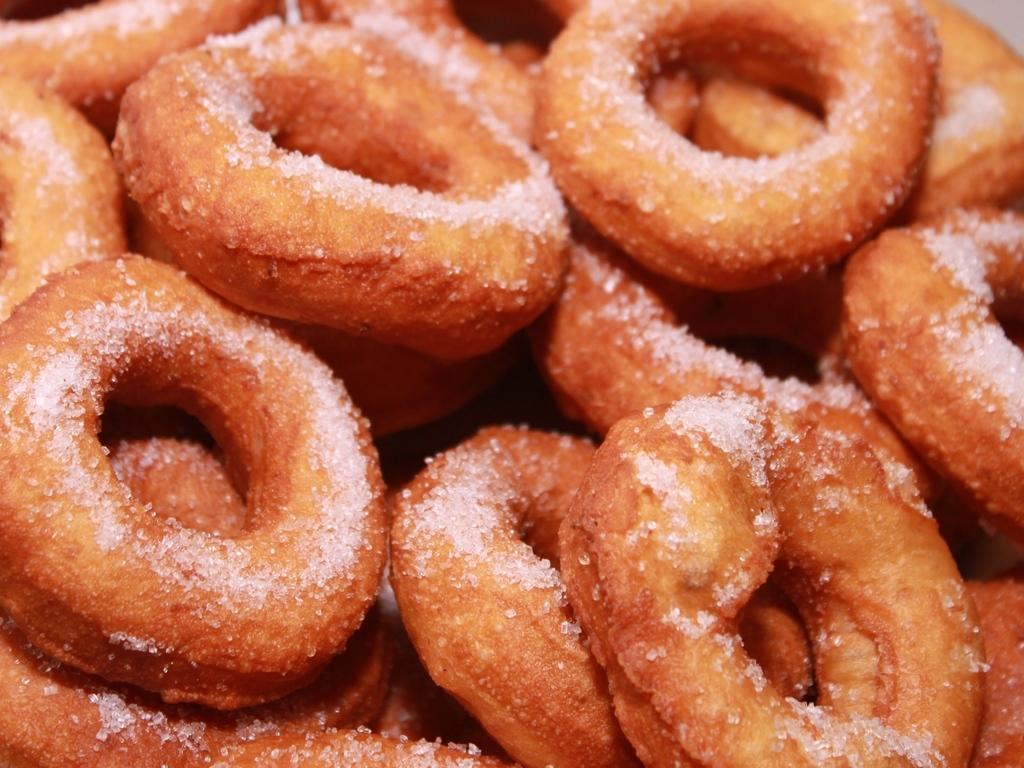Please provide a concise description of this image. There are doughnuts with sugar topping. 